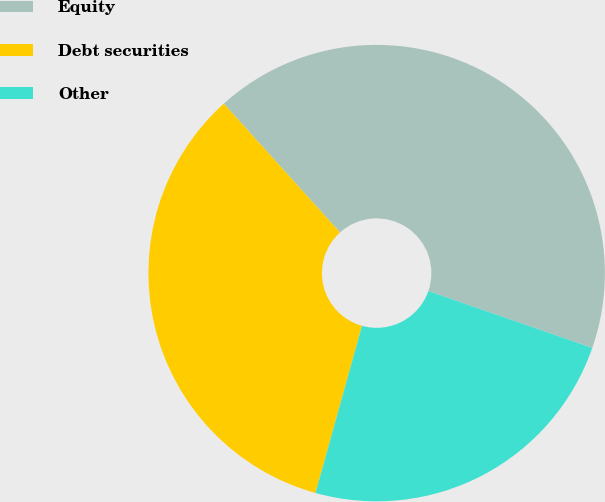<chart> <loc_0><loc_0><loc_500><loc_500><pie_chart><fcel>Equity<fcel>Debt securities<fcel>Other<nl><fcel>42.0%<fcel>34.0%<fcel>24.0%<nl></chart> 